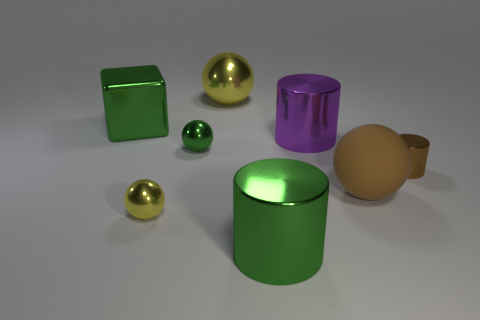Is there anything else that is made of the same material as the brown sphere?
Offer a terse response. No. How many cylinders are shiny objects or small objects?
Give a very brief answer. 3. The metallic block has what color?
Keep it short and to the point. Green. Is the size of the thing to the right of the large brown matte ball the same as the green cube that is behind the green shiny cylinder?
Your answer should be very brief. No. Is the number of small yellow cylinders less than the number of objects?
Your answer should be very brief. Yes. There is a small yellow ball; how many small green metal spheres are on the right side of it?
Give a very brief answer. 1. What is the material of the brown ball?
Ensure brevity in your answer.  Rubber. Does the shiny cube have the same color as the big matte thing?
Provide a succinct answer. No. Is the number of matte balls to the left of the block less than the number of green cubes?
Your answer should be compact. Yes. What color is the sphere that is behind the big green block?
Keep it short and to the point. Yellow. 